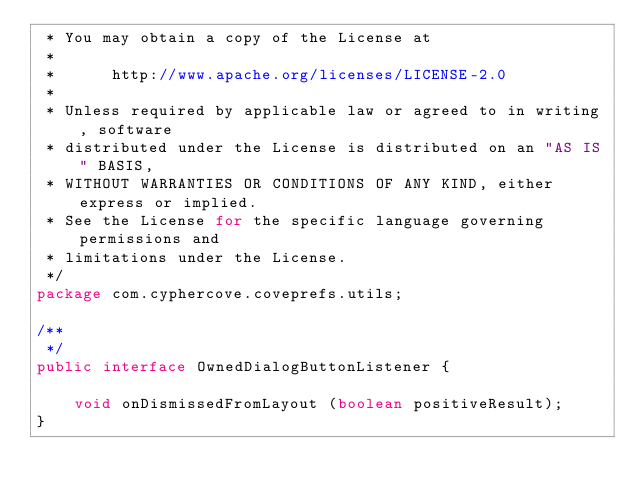Convert code to text. <code><loc_0><loc_0><loc_500><loc_500><_Java_> * You may obtain a copy of the License at
 *
 *      http://www.apache.org/licenses/LICENSE-2.0
 *
 * Unless required by applicable law or agreed to in writing, software
 * distributed under the License is distributed on an "AS IS" BASIS,
 * WITHOUT WARRANTIES OR CONDITIONS OF ANY KIND, either express or implied.
 * See the License for the specific language governing permissions and
 * limitations under the License.
 */
package com.cyphercove.coveprefs.utils;

/**
 */
public interface OwnedDialogButtonListener {

    void onDismissedFromLayout (boolean positiveResult);
}
</code> 